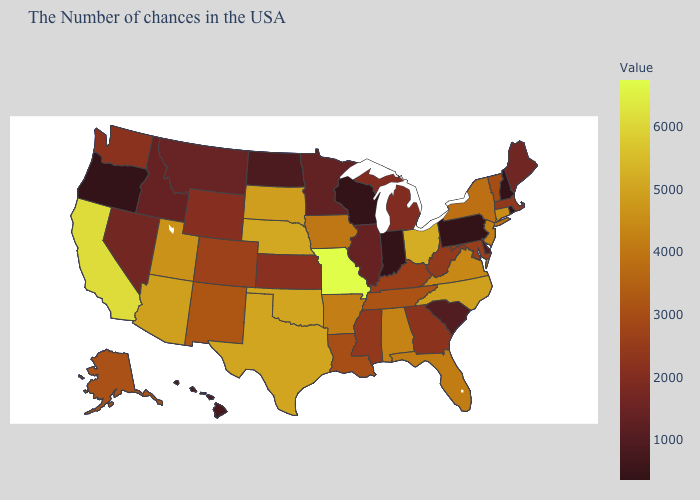Which states have the highest value in the USA?
Keep it brief. Missouri. 